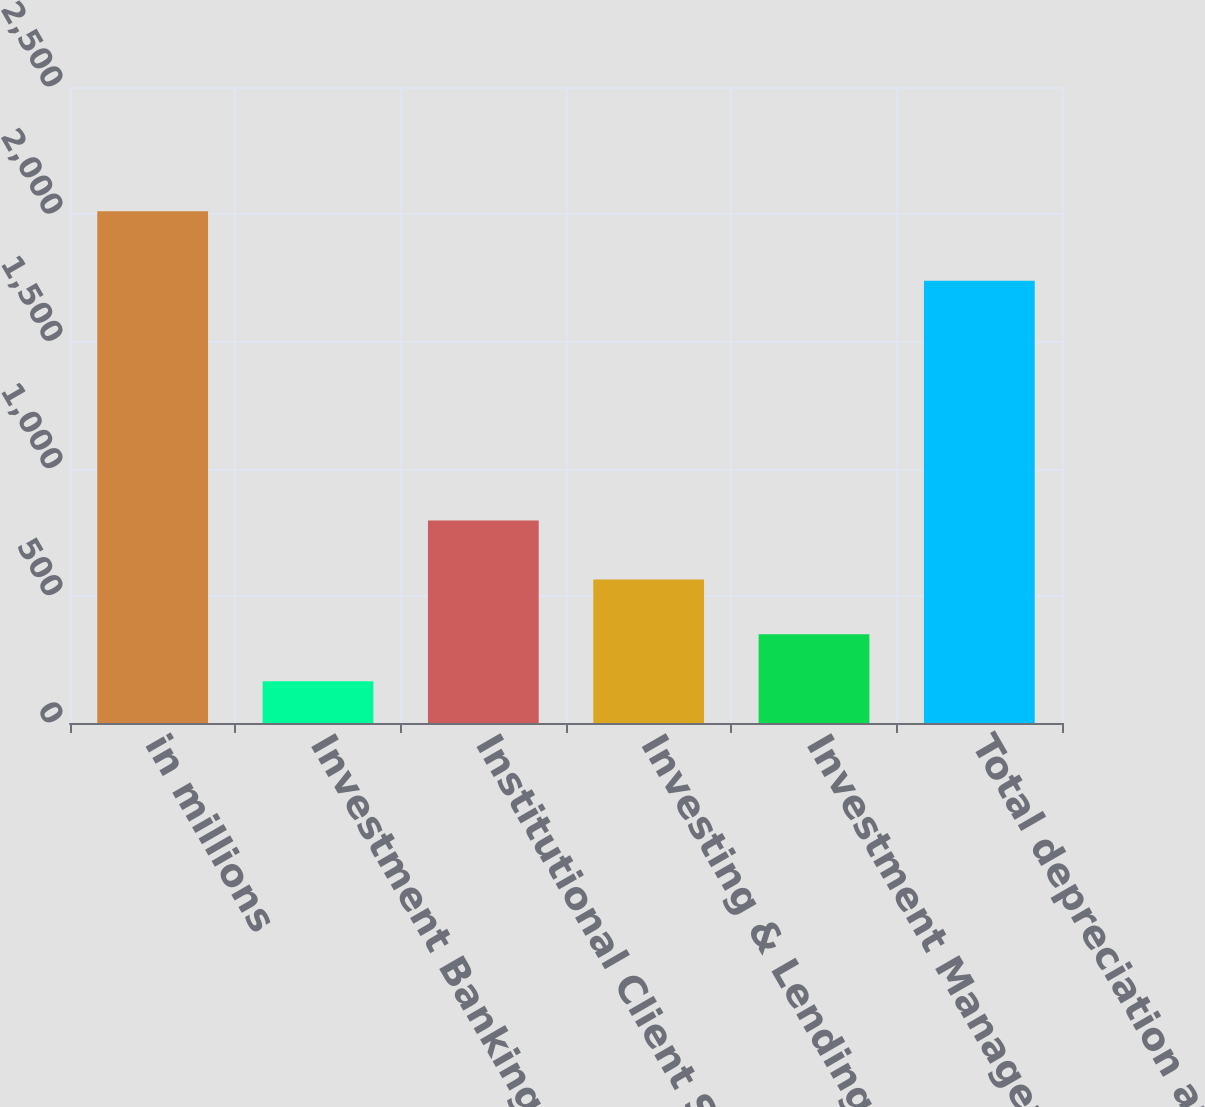Convert chart to OTSL. <chart><loc_0><loc_0><loc_500><loc_500><bar_chart><fcel>in millions<fcel>Investment Banking<fcel>Institutional Client Services<fcel>Investing & Lending<fcel>Investment Management<fcel>Total depreciation and<nl><fcel>2012<fcel>164<fcel>796<fcel>564<fcel>348.8<fcel>1738<nl></chart> 